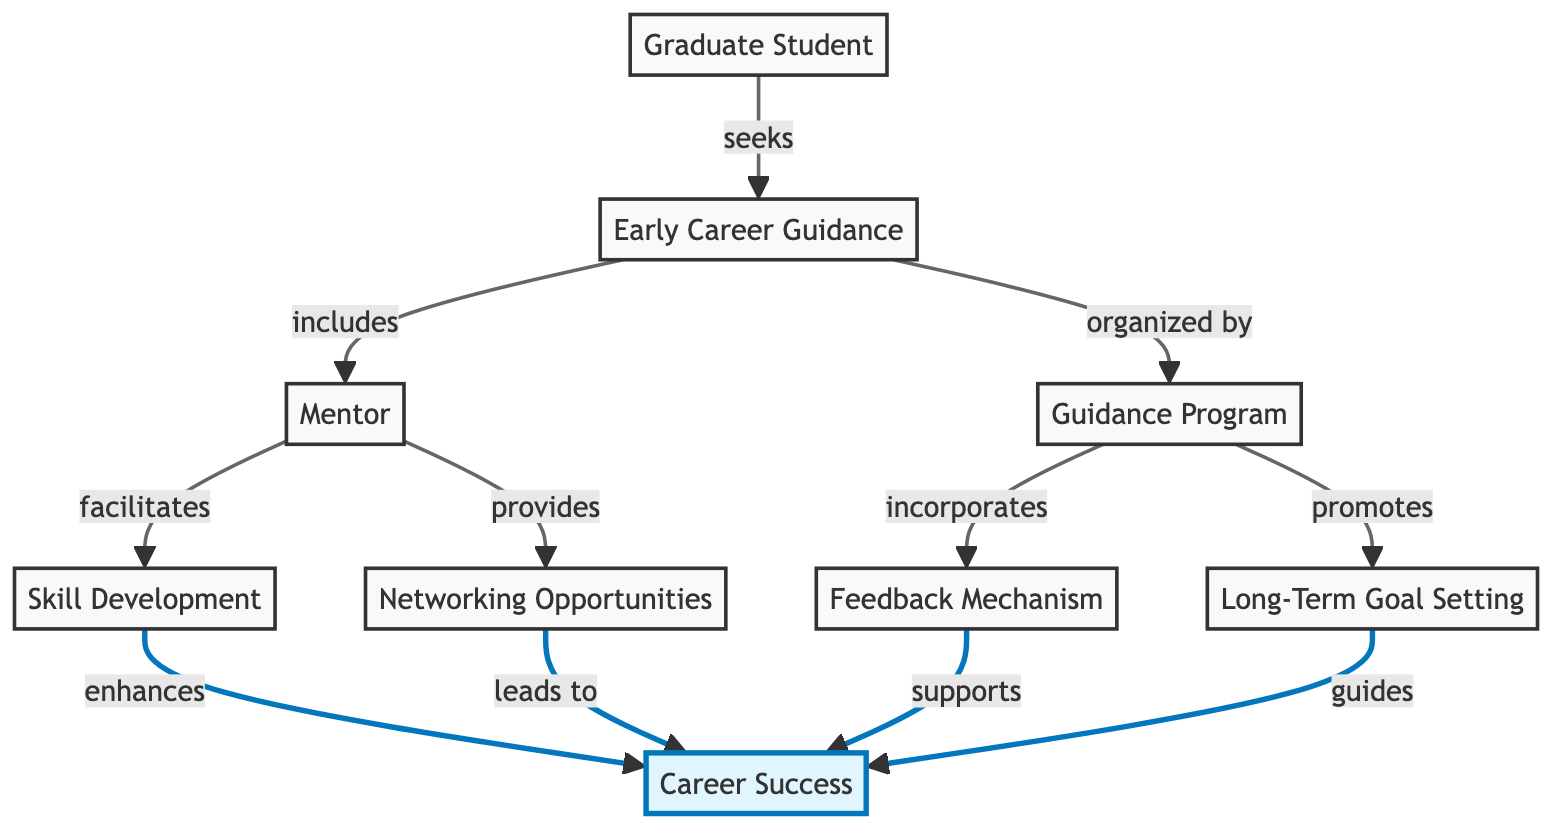What is the main role of the mentor in this diagram? The mentor's role is to provide networking opportunities and facilitate skill development for the graduate student. This is evident from the directed edges going from the mentor to both networking opportunities and skill development.
Answer: provides, facilitates How many nodes are present in the diagram? The diagram includes 9 distinct nodes: graduate student, early career guidance, mentor, guidance program, networking opportunities, skill development, career success, long-term goal setting, and feedback mechanism.
Answer: 9 Which entity is connected to the career success node through skill development? The entity connected to the career success node through skill development is the skill development node itself, as indicated by the directed edge from skill development to career success.
Answer: skill development What does the guidance program incorporate? According to the diagram, the guidance program incorporates a feedback mechanism, as shown by the directed edge from guidance program to feedback mechanism.
Answer: feedback mechanism Which node leads to career success through networking opportunities? The node that leads to career success through networking opportunities is the networking opportunities node itself, as represented by the directed edge from it to career success.
Answer: networking opportunities How does early career guidance relate to mentorship? Early career guidance includes the mentor, as indicated by the directed edge from early career guidance to mentor. This shows that mentorship is a component of early career guidance initiatives.
Answer: includes What is the final result achieved after long-term goal setting? The final result achieved after long-term goal setting is career success, which is indicated by the directed edge from long-term goal setting to career success in the diagram.
Answer: career success Identify the relationship between guidance program and long-term goal setting. The guidance program promotes long-term goal setting, based on the directed edge from guidance program to long-term goal setting. This indicates a direct supportive relationship between the two.
Answer: promotes What does feedback mechanism support in the context of this diagram? The feedback mechanism supports career success, as shown by the directed edge from feedback mechanism to career success. This implies that feedback is essential for achieving success in a career.
Answer: supports 